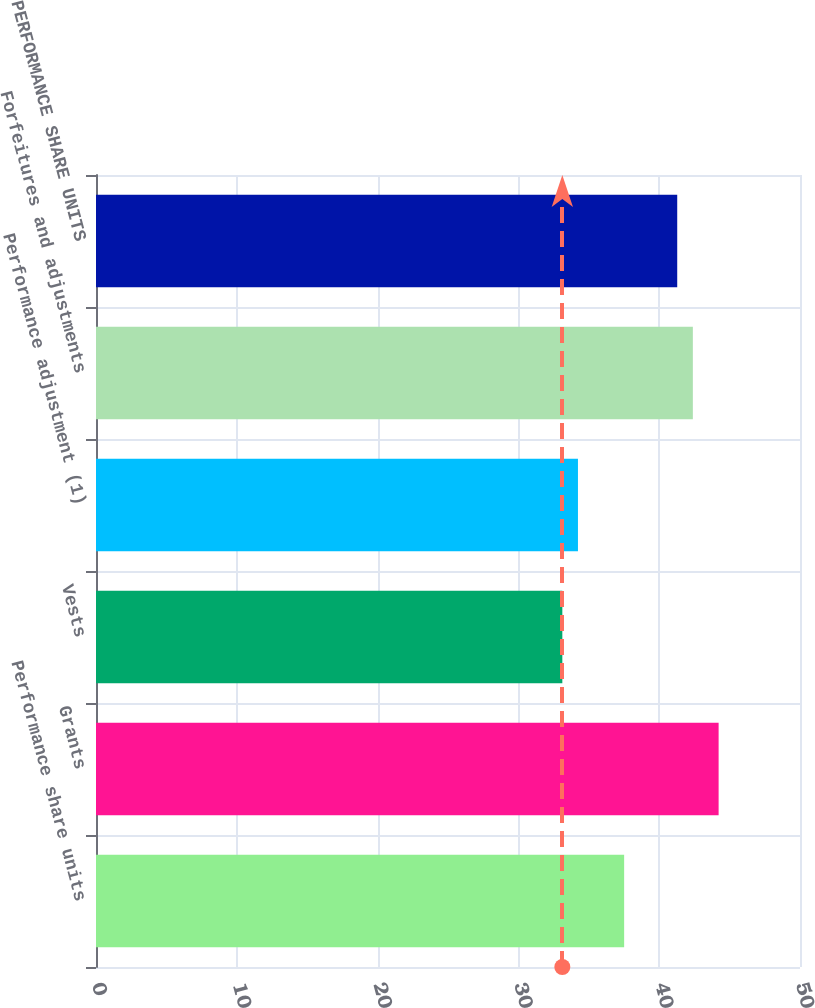<chart> <loc_0><loc_0><loc_500><loc_500><bar_chart><fcel>Performance share units<fcel>Grants<fcel>Vests<fcel>Performance adjustment (1)<fcel>Forfeitures and adjustments<fcel>PERFORMANCE SHARE UNITS<nl><fcel>37.51<fcel>44.22<fcel>33.12<fcel>34.23<fcel>42.39<fcel>41.28<nl></chart> 